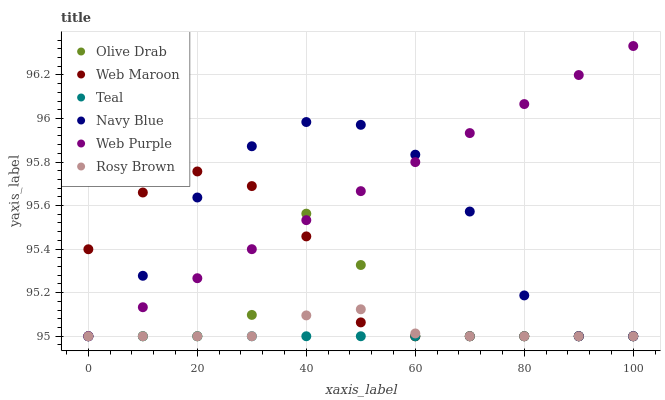Does Teal have the minimum area under the curve?
Answer yes or no. Yes. Does Web Purple have the maximum area under the curve?
Answer yes or no. Yes. Does Rosy Brown have the minimum area under the curve?
Answer yes or no. No. Does Rosy Brown have the maximum area under the curve?
Answer yes or no. No. Is Teal the smoothest?
Answer yes or no. Yes. Is Olive Drab the roughest?
Answer yes or no. Yes. Is Rosy Brown the smoothest?
Answer yes or no. No. Is Rosy Brown the roughest?
Answer yes or no. No. Does Navy Blue have the lowest value?
Answer yes or no. Yes. Does Web Purple have the highest value?
Answer yes or no. Yes. Does Rosy Brown have the highest value?
Answer yes or no. No. Does Rosy Brown intersect Web Purple?
Answer yes or no. Yes. Is Rosy Brown less than Web Purple?
Answer yes or no. No. Is Rosy Brown greater than Web Purple?
Answer yes or no. No. 